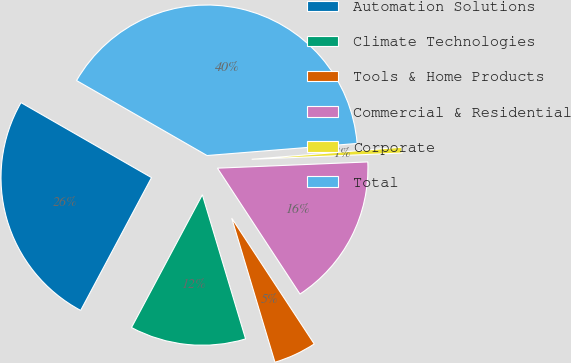Convert chart to OTSL. <chart><loc_0><loc_0><loc_500><loc_500><pie_chart><fcel>Automation Solutions<fcel>Climate Technologies<fcel>Tools & Home Products<fcel>Commercial & Residential<fcel>Corporate<fcel>Total<nl><fcel>25.5%<fcel>12.44%<fcel>4.6%<fcel>16.42%<fcel>0.62%<fcel>40.42%<nl></chart> 